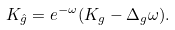Convert formula to latex. <formula><loc_0><loc_0><loc_500><loc_500>K _ { \hat { g } } = e ^ { - \omega } ( K _ { g } - \Delta _ { g } \omega ) .</formula> 